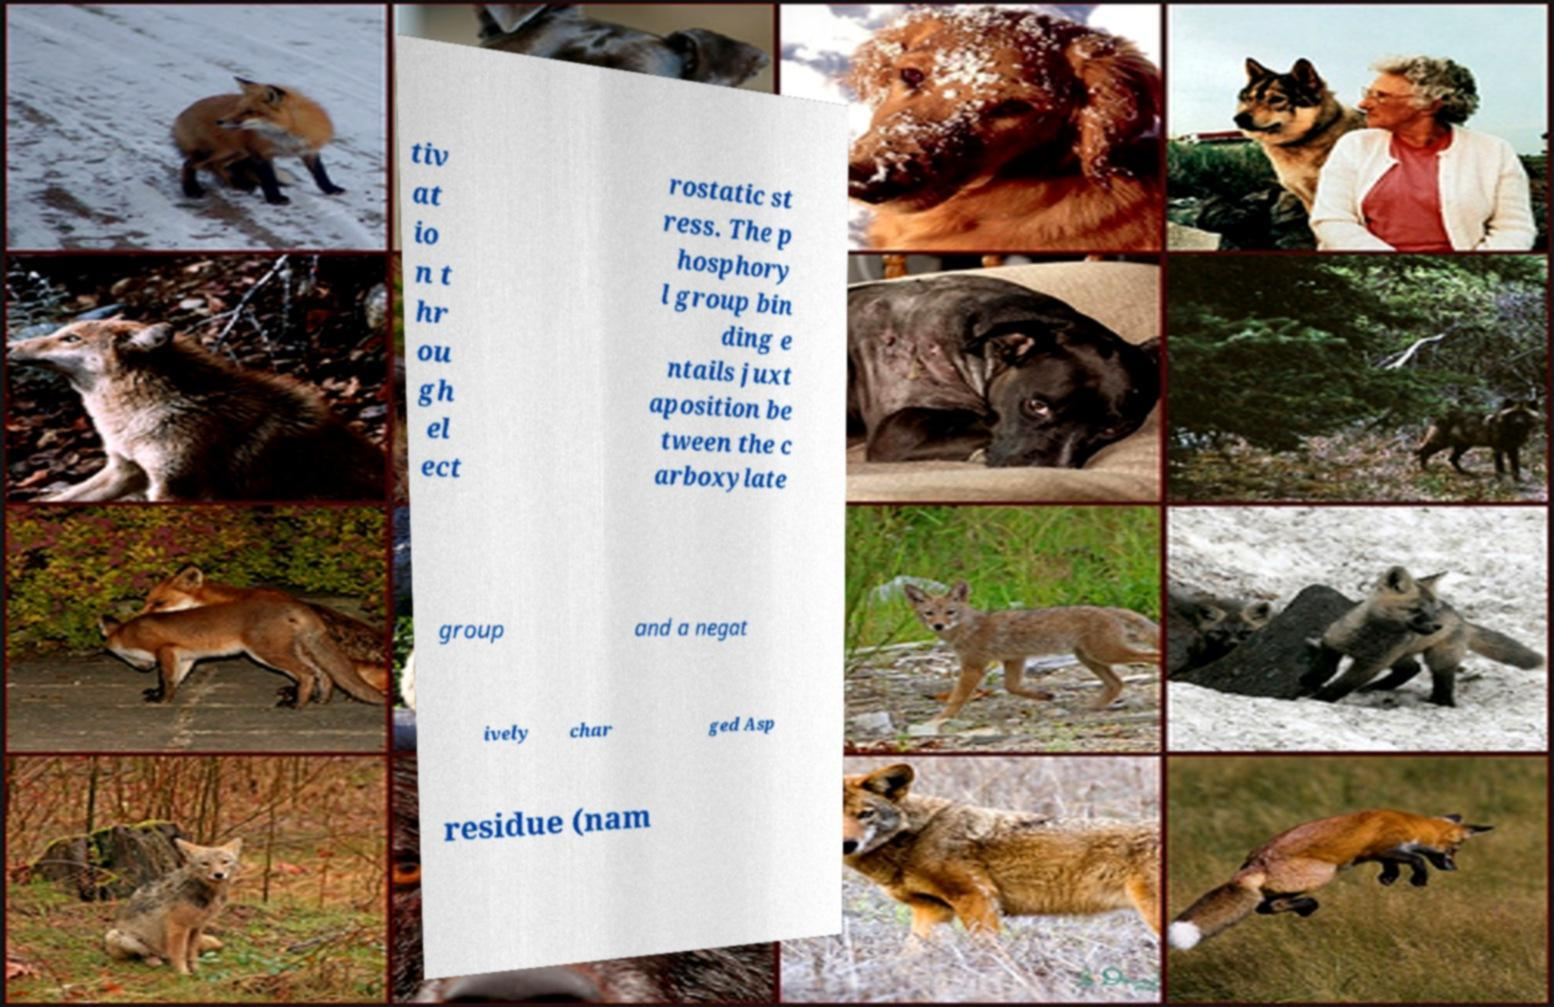Could you assist in decoding the text presented in this image and type it out clearly? tiv at io n t hr ou gh el ect rostatic st ress. The p hosphory l group bin ding e ntails juxt aposition be tween the c arboxylate group and a negat ively char ged Asp residue (nam 